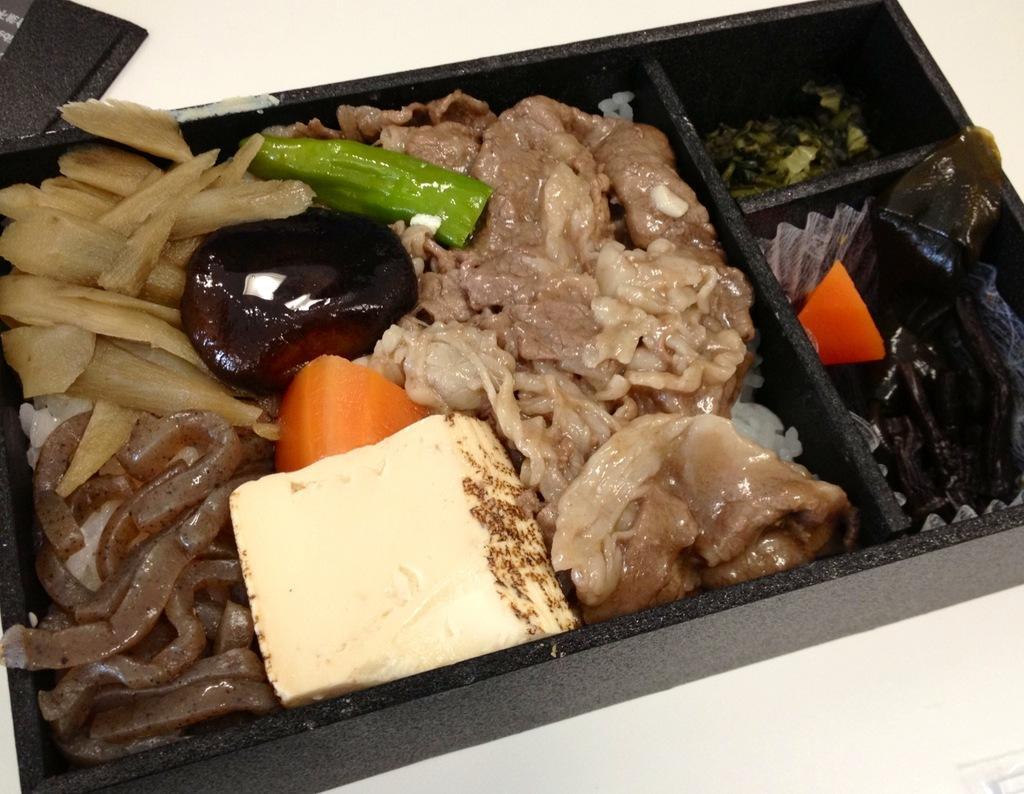Please provide a concise description of this image. In the foreground of this image, there are food items in a black tray on a white surface. At the top, there is an object. 